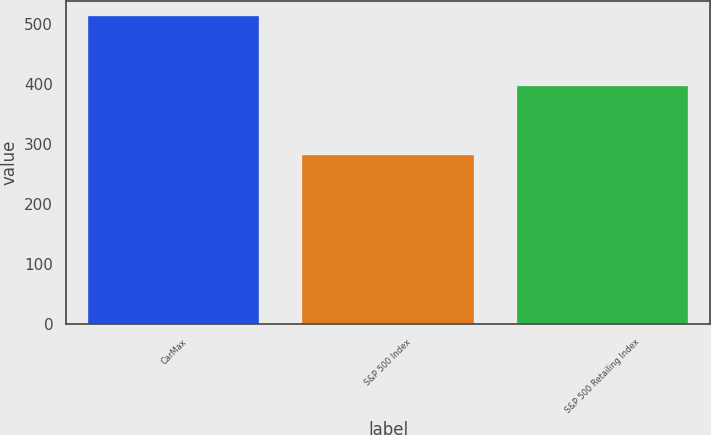<chart> <loc_0><loc_0><loc_500><loc_500><bar_chart><fcel>CarMax<fcel>S&P 500 Index<fcel>S&P 500 Retailing Index<nl><fcel>513.57<fcel>281.57<fcel>397.86<nl></chart> 